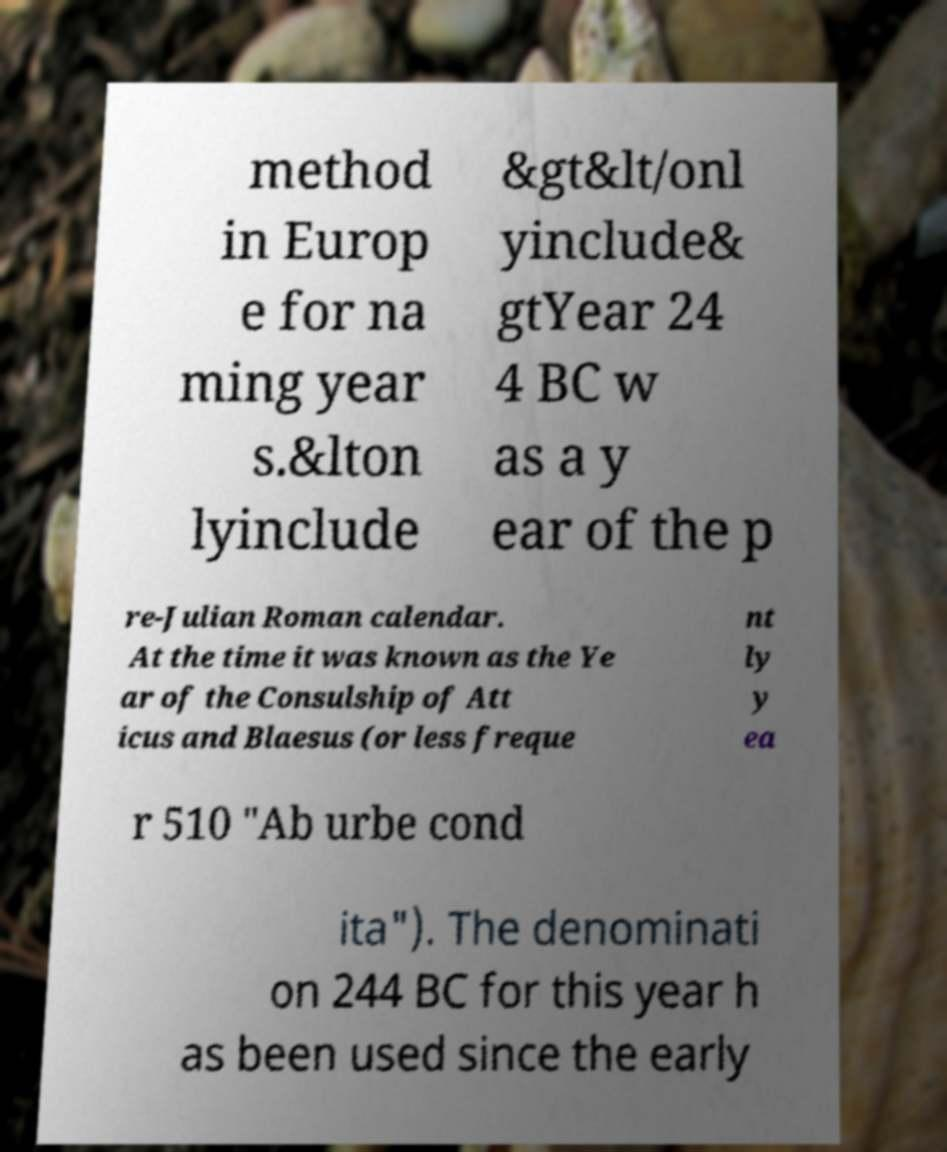Please identify and transcribe the text found in this image. method in Europ e for na ming year s.&lton lyinclude &gt&lt/onl yinclude& gtYear 24 4 BC w as a y ear of the p re-Julian Roman calendar. At the time it was known as the Ye ar of the Consulship of Att icus and Blaesus (or less freque nt ly y ea r 510 "Ab urbe cond ita"). The denominati on 244 BC for this year h as been used since the early 